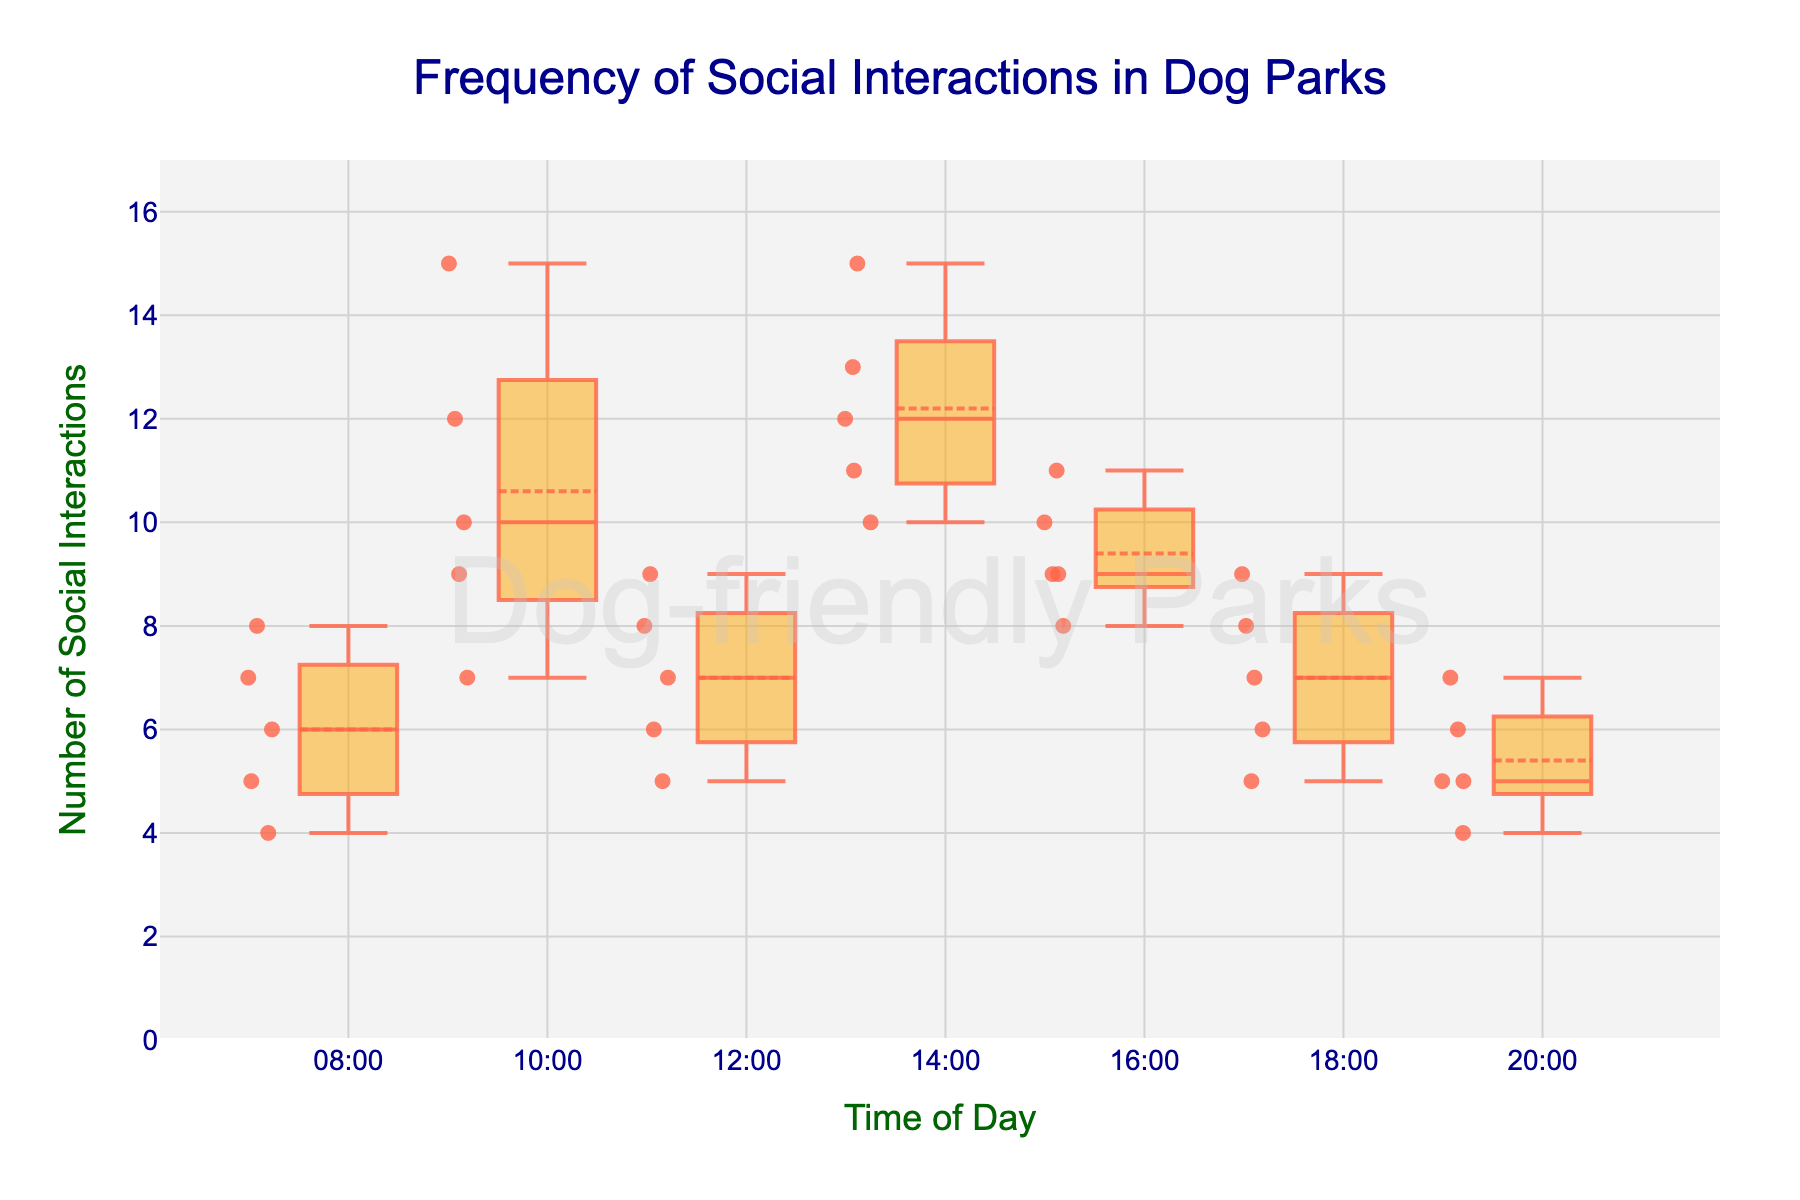What is the title of the plot? The title is displayed at the top of the figure. It reads "Frequency of Social Interactions in Dog Parks."
Answer: Frequency of Social Interactions in Dog Parks What is the range of social interactions observed? The y-axis shows the range of social interactions, which goes from 0 to 17 (as it is max value + 2).
Answer: 0 to 17 At which time of day do dogs have the lowest median frequency of social interactions? The median line is usually in the middle of each box plot. The median for 20:00 appears to be comparatively the lowest among all the times.
Answer: 20:00 Which time of day has the highest upper whisker? The upper whisker represents the maximum value excluding any potential outliers. The box plot for 10:00 has the highest upper whisker, going up to 15 social interactions.
Answer: 10:00 What is the interquartile range (IQR) for social interactions at 14:00? The IQR is the difference between the upper quartile (75th percentile) and the lower quartile (25th percentile). For 14:00, the lower quartile is roughly 11, and the upper quartile is about 13. Therefore, the IQR is 13 - 11.
Answer: 2 Which time period displays the most consistent number of social interactions (least variability)? Consistency can be judged by the height of the boxes. Shorter boxes indicate less variability. The box for 16:00 seems the shortest, suggesting the least variability in social interactions.
Answer: 16:00 How many outliers are there in the plot? Outliers are data points that are plotted individually beyond the whiskers of the box plot. There do not appear to be any individual points far outside the whiskers in this plot.
Answer: 0 How does the median number of social interactions at 08:00 compare to 10:00? The median is represented by the horizontal line inside each box. The median at 10:00 is higher compared to 08:00.
Answer: 10:00 is higher At what time of day do we see the widest range of social interactions? The range is widest when the distance between the whiskers is largest. The time period 10:00 shows the widest range from about 7 to 15 social interactions.
Answer: 10:00 Does the plot show any trend in the frequency of social interactions across the times of day? The plot does not show a clear increasing or decreasing trend in social interactions throughout the day.
Answer: No clear trend 